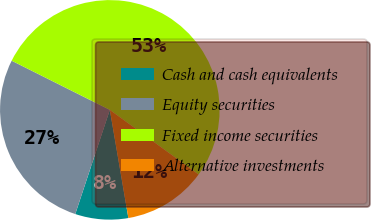Convert chart to OTSL. <chart><loc_0><loc_0><loc_500><loc_500><pie_chart><fcel>Cash and cash equivalents<fcel>Equity securities<fcel>Fixed income securities<fcel>Alternative investments<nl><fcel>7.8%<fcel>27.29%<fcel>52.63%<fcel>12.28%<nl></chart> 